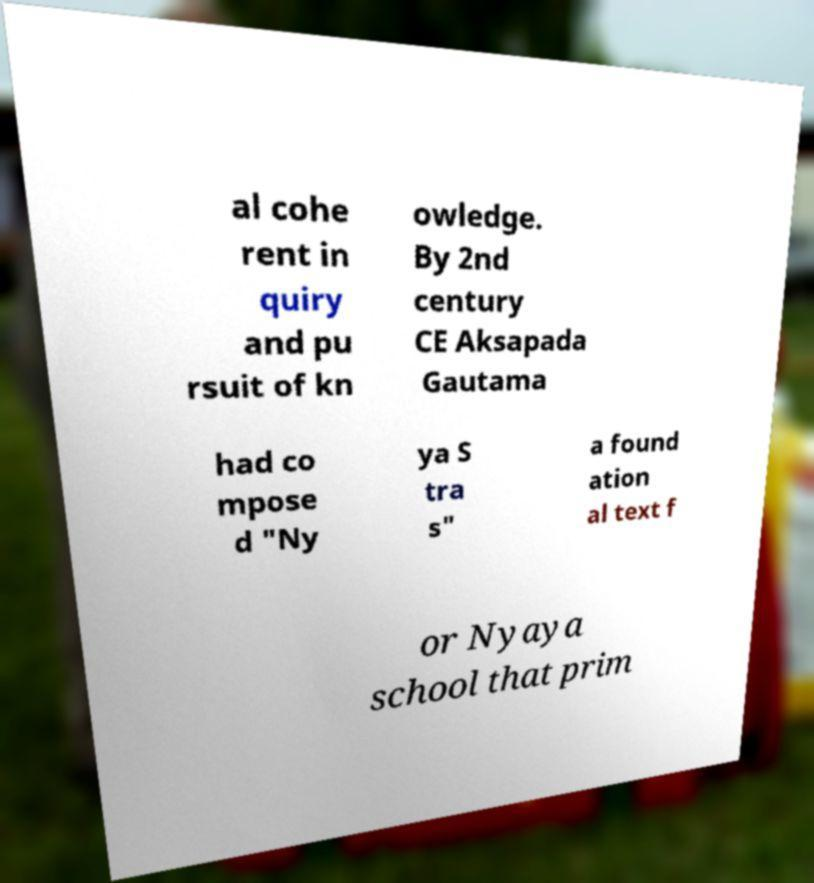Please read and relay the text visible in this image. What does it say? al cohe rent in quiry and pu rsuit of kn owledge. By 2nd century CE Aksapada Gautama had co mpose d "Ny ya S tra s" a found ation al text f or Nyaya school that prim 